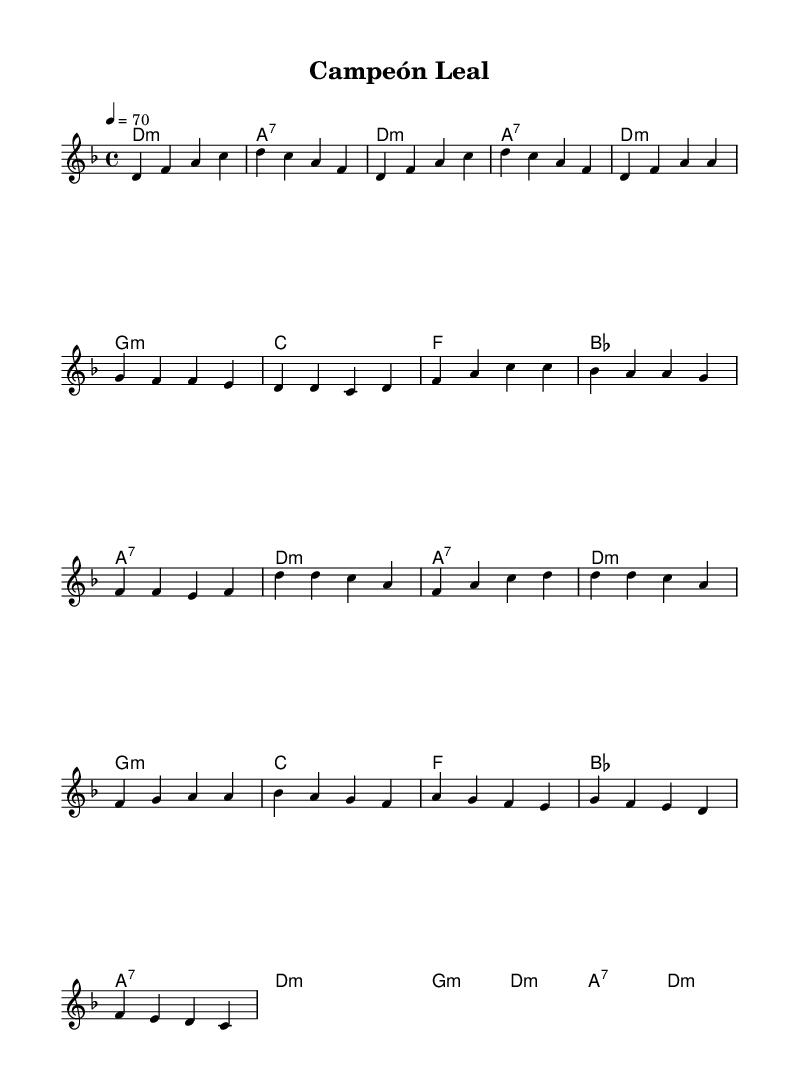What is the key signature of this music? The key signature is D minor, indicated by one flat (B♭) in the key signature diagram.
Answer: D minor What is the time signature of this music? The time signature is 4/4, which means there are four beats per measure and a quarter note receives one beat.
Answer: 4/4 What is the tempo marking for this piece? The tempo marking states "4 = 70," which indicates the quarter note is to be played at a speed of 70 beats per minute.
Answer: 70 How many sections are there in the music? The music consists of four main sections: Intro, Verse, Chorus, and Bridge, which are distinct parts of the composition.
Answer: Four What is the first chord in the piece? The first chord is D minor, as displayed in the chord progression at the beginning of the sheet music where it indicates the harmonic structure.
Answer: D minor What is the overall mood conveyed by the melody based on its intervals? The melody suggests a reflective and emotional mood, as it uses a mix of rising and falling intervals that evoke feelings of nostalgia and contemplation.
Answer: Emotional Which section contains the repetition of the melody? The Chorus section contains the repetition of the melody, as it revisits the earlier material, which is a common trait in ballads.
Answer: Chorus 